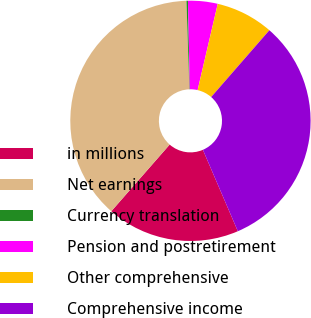Convert chart. <chart><loc_0><loc_0><loc_500><loc_500><pie_chart><fcel>in millions<fcel>Net earnings<fcel>Currency translation<fcel>Pension and postretirement<fcel>Other comprehensive<fcel>Comprehensive income<nl><fcel>17.9%<fcel>38.03%<fcel>0.2%<fcel>3.98%<fcel>7.76%<fcel>32.14%<nl></chart> 